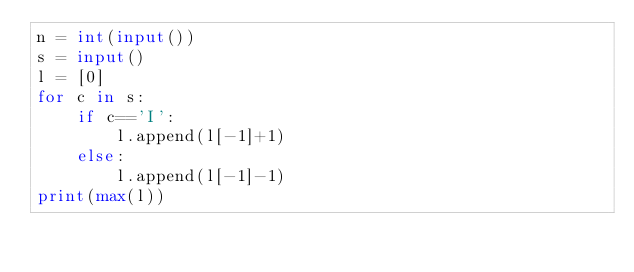<code> <loc_0><loc_0><loc_500><loc_500><_Python_>n = int(input())
s = input()
l = [0]
for c in s:
    if c=='I':
        l.append(l[-1]+1)
    else:
        l.append(l[-1]-1)
print(max(l))
</code> 